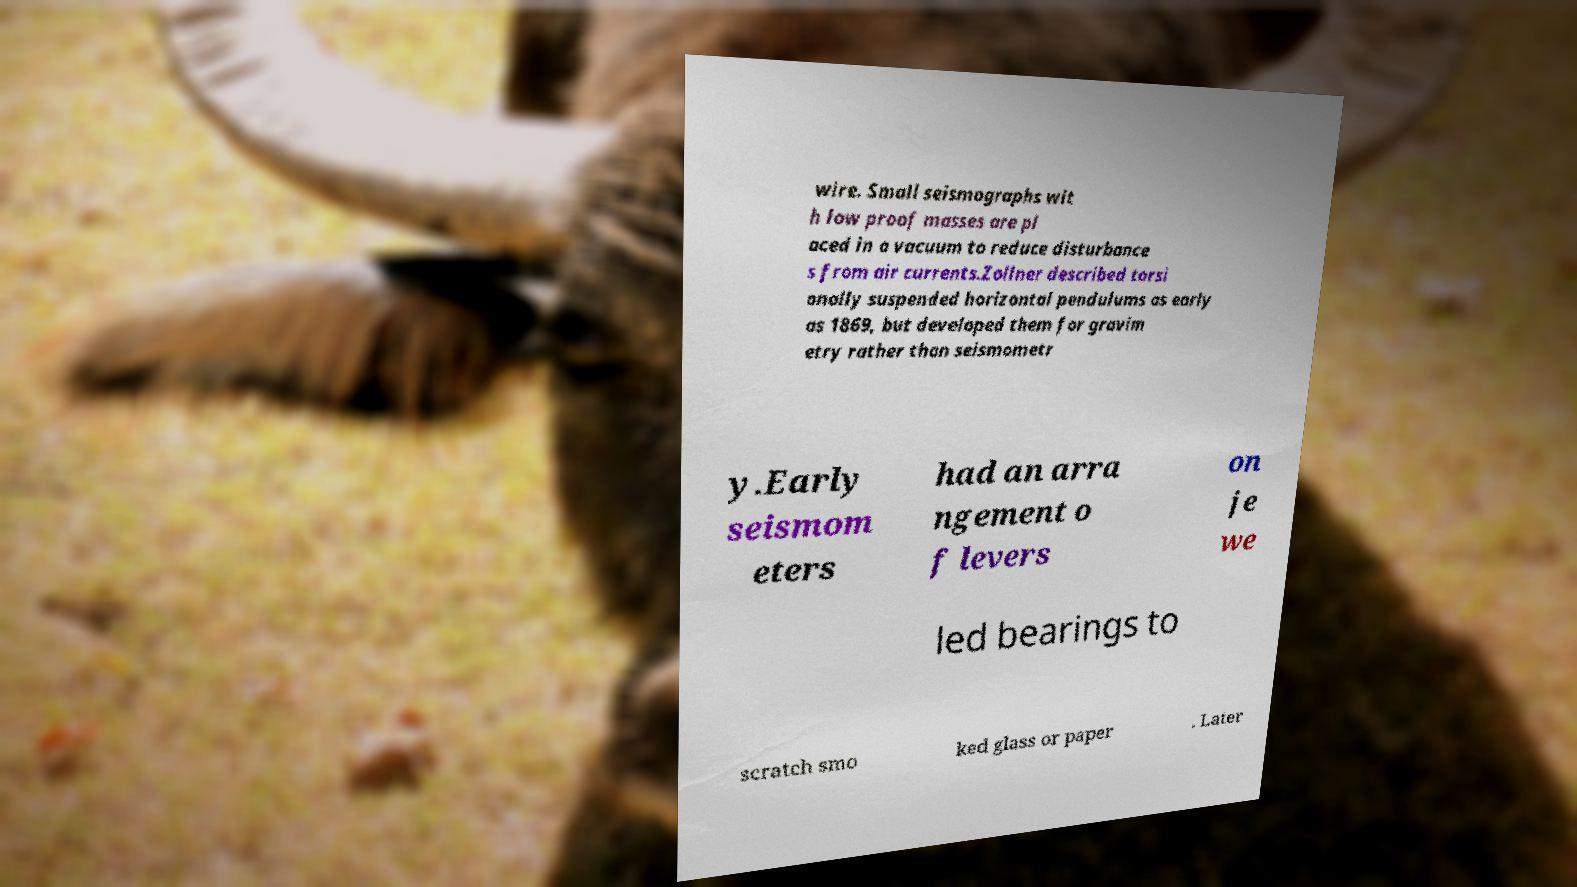Can you read and provide the text displayed in the image?This photo seems to have some interesting text. Can you extract and type it out for me? wire. Small seismographs wit h low proof masses are pl aced in a vacuum to reduce disturbance s from air currents.Zollner described torsi onally suspended horizontal pendulums as early as 1869, but developed them for gravim etry rather than seismometr y.Early seismom eters had an arra ngement o f levers on je we led bearings to scratch smo ked glass or paper . Later 